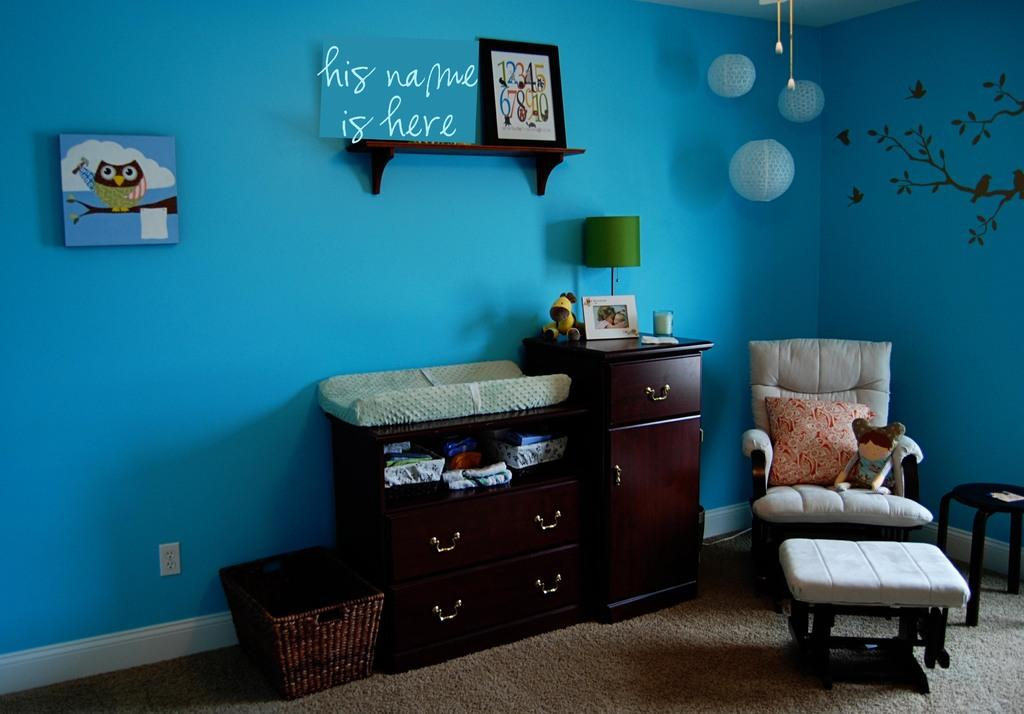What color is the room painted in the image? The room is painted in sky blue. What can be found in the room besides the walls? There is furniture and a lamp in the room. Are there any decorations on the walls in the room? Yes, there are frames on the wall. How many pizzas are being served in the room? There is no mention of pizzas in the image, so it cannot be determined how many are being served. 